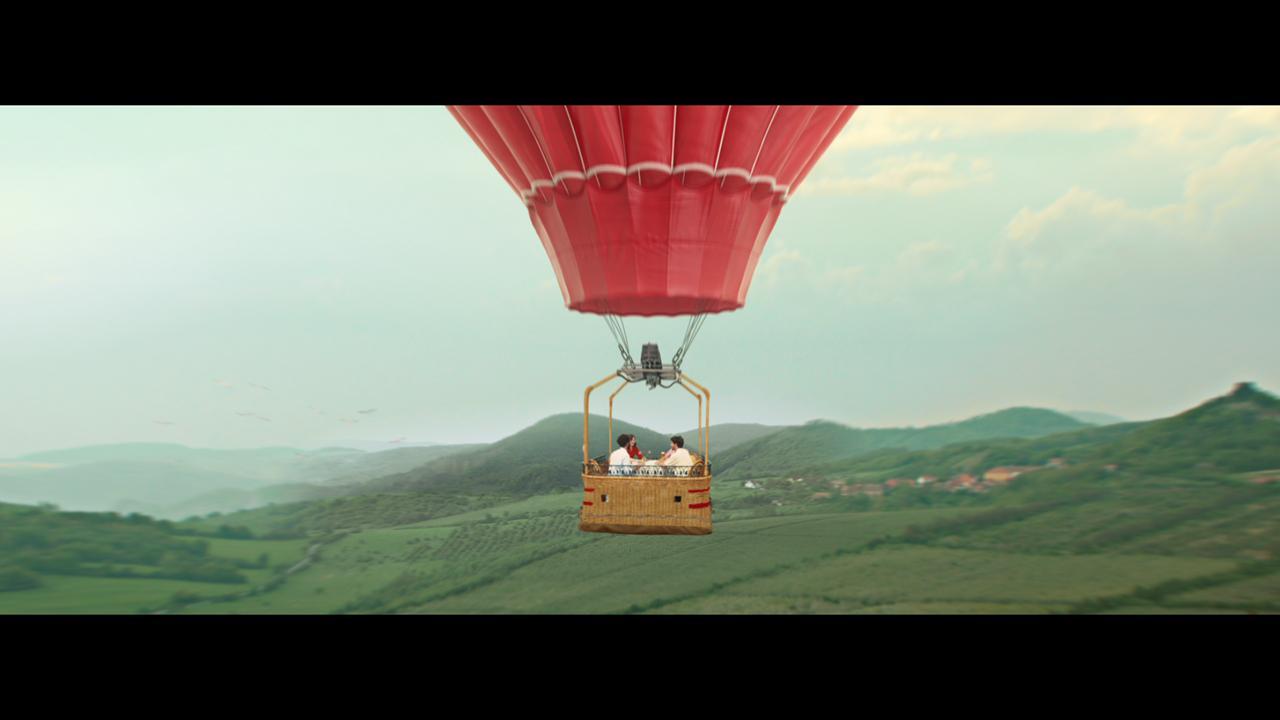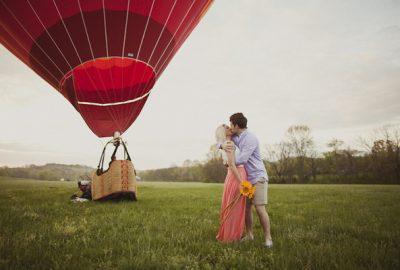The first image is the image on the left, the second image is the image on the right. For the images displayed, is the sentence "The balloon is in the air in the image on the left." factually correct? Answer yes or no. Yes. The first image is the image on the left, the second image is the image on the right. Examine the images to the left and right. Is the description "An image shows a solid-red balloon floating above a green field." accurate? Answer yes or no. Yes. 